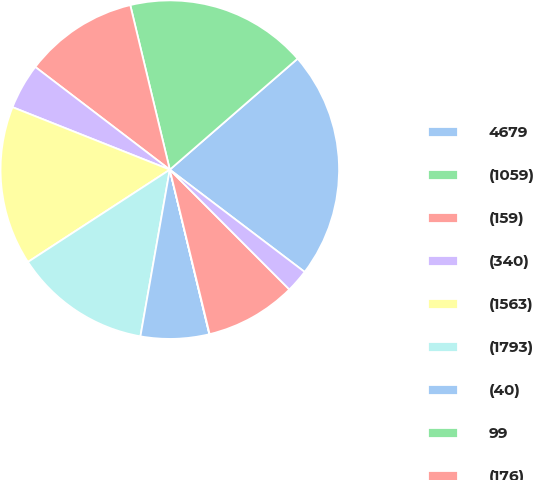Convert chart to OTSL. <chart><loc_0><loc_0><loc_500><loc_500><pie_chart><fcel>4679<fcel>(1059)<fcel>(159)<fcel>(340)<fcel>(1563)<fcel>(1793)<fcel>(40)<fcel>99<fcel>(176)<fcel>855<nl><fcel>21.71%<fcel>17.37%<fcel>10.87%<fcel>4.36%<fcel>15.2%<fcel>13.04%<fcel>6.53%<fcel>0.03%<fcel>8.7%<fcel>2.19%<nl></chart> 